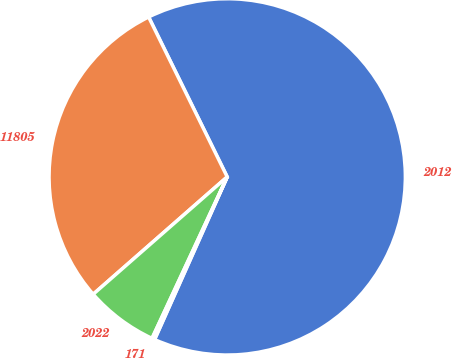Convert chart to OTSL. <chart><loc_0><loc_0><loc_500><loc_500><pie_chart><fcel>2012<fcel>11805<fcel>2022<fcel>171<nl><fcel>63.96%<fcel>29.18%<fcel>6.62%<fcel>0.25%<nl></chart> 